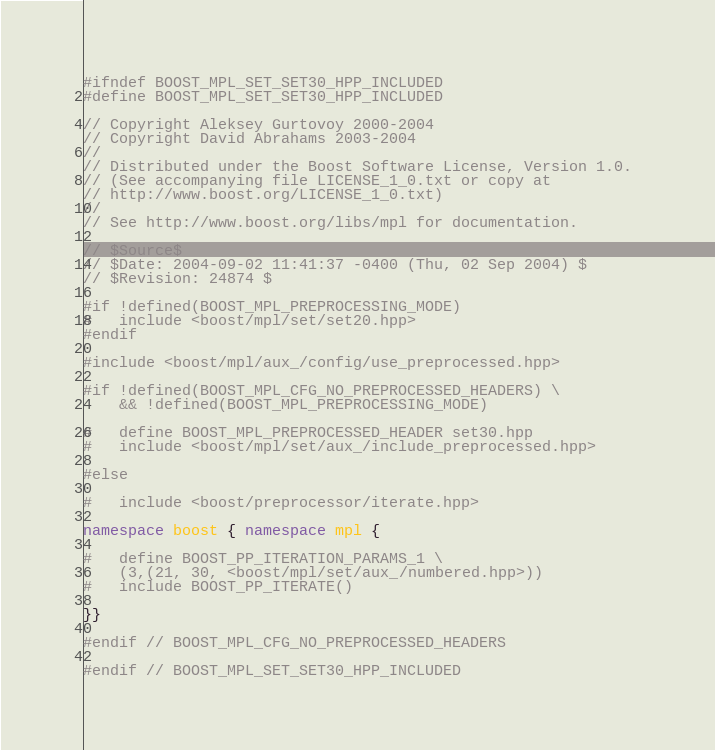Convert code to text. <code><loc_0><loc_0><loc_500><loc_500><_C++_>
#ifndef BOOST_MPL_SET_SET30_HPP_INCLUDED
#define BOOST_MPL_SET_SET30_HPP_INCLUDED

// Copyright Aleksey Gurtovoy 2000-2004
// Copyright David Abrahams 2003-2004
//
// Distributed under the Boost Software License, Version 1.0. 
// (See accompanying file LICENSE_1_0.txt or copy at 
// http://www.boost.org/LICENSE_1_0.txt)
//
// See http://www.boost.org/libs/mpl for documentation.

// $Source$
// $Date: 2004-09-02 11:41:37 -0400 (Thu, 02 Sep 2004) $
// $Revision: 24874 $

#if !defined(BOOST_MPL_PREPROCESSING_MODE)
#   include <boost/mpl/set/set20.hpp>
#endif

#include <boost/mpl/aux_/config/use_preprocessed.hpp>

#if !defined(BOOST_MPL_CFG_NO_PREPROCESSED_HEADERS) \
    && !defined(BOOST_MPL_PREPROCESSING_MODE)

#   define BOOST_MPL_PREPROCESSED_HEADER set30.hpp
#   include <boost/mpl/set/aux_/include_preprocessed.hpp>

#else

#   include <boost/preprocessor/iterate.hpp>

namespace boost { namespace mpl {

#   define BOOST_PP_ITERATION_PARAMS_1 \
    (3,(21, 30, <boost/mpl/set/aux_/numbered.hpp>))
#   include BOOST_PP_ITERATE()

}}

#endif // BOOST_MPL_CFG_NO_PREPROCESSED_HEADERS

#endif // BOOST_MPL_SET_SET30_HPP_INCLUDED
</code> 